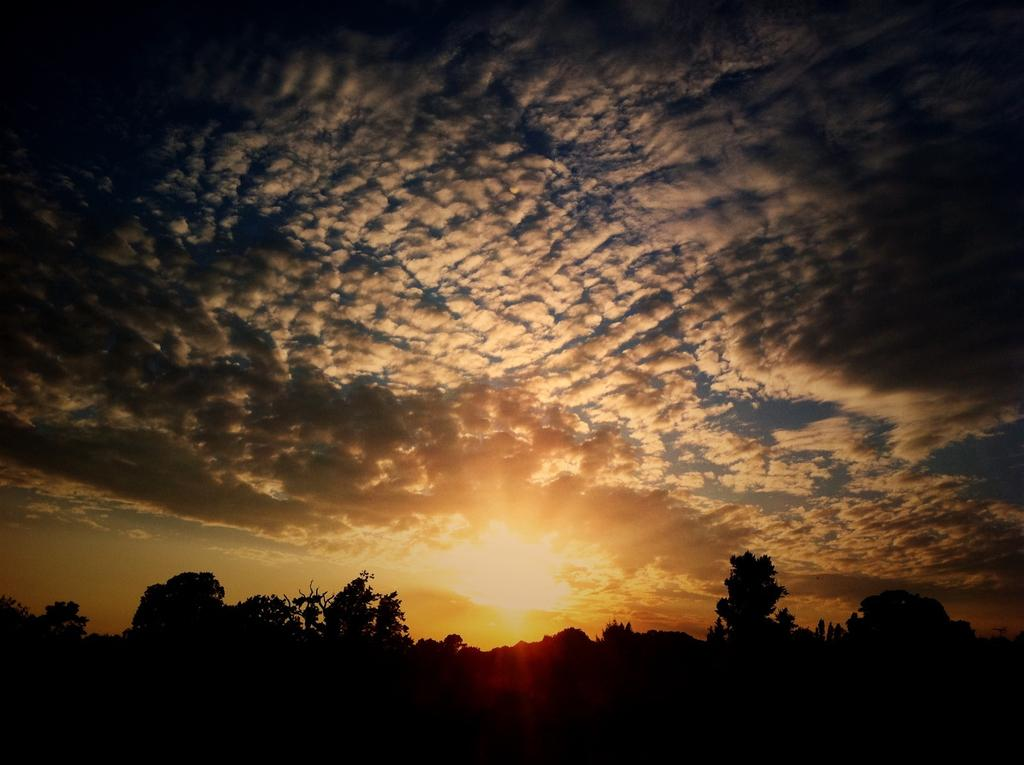What time of day is depicted in the image? The image is taken during sunset. What can be seen in the sky in the image? There is sky visible in the image, with clouds and the sun present. What type of vegetation is at the bottom of the image? There are trees at the bottom of the image. How many discussions are taking place in the image? There is no indication of any discussions happening in the image. Can you tell me the age of the aunt in the image? There is no aunt present in the image. 